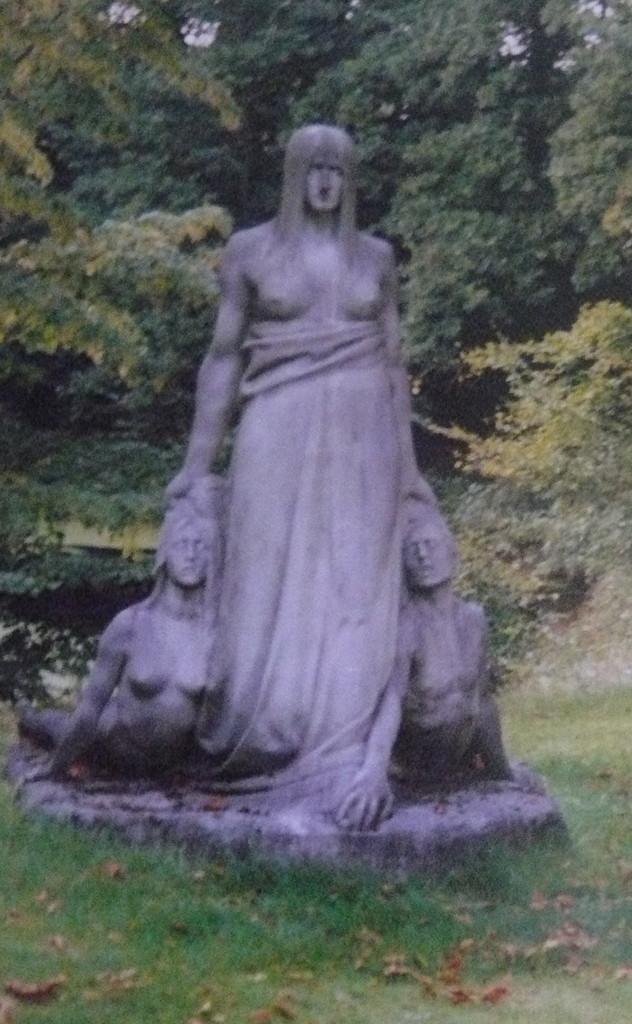Can you describe this image briefly? In this image I can see a statue of three persons on the ground. I can see few leaves, some grass and few trees which are green in color. 